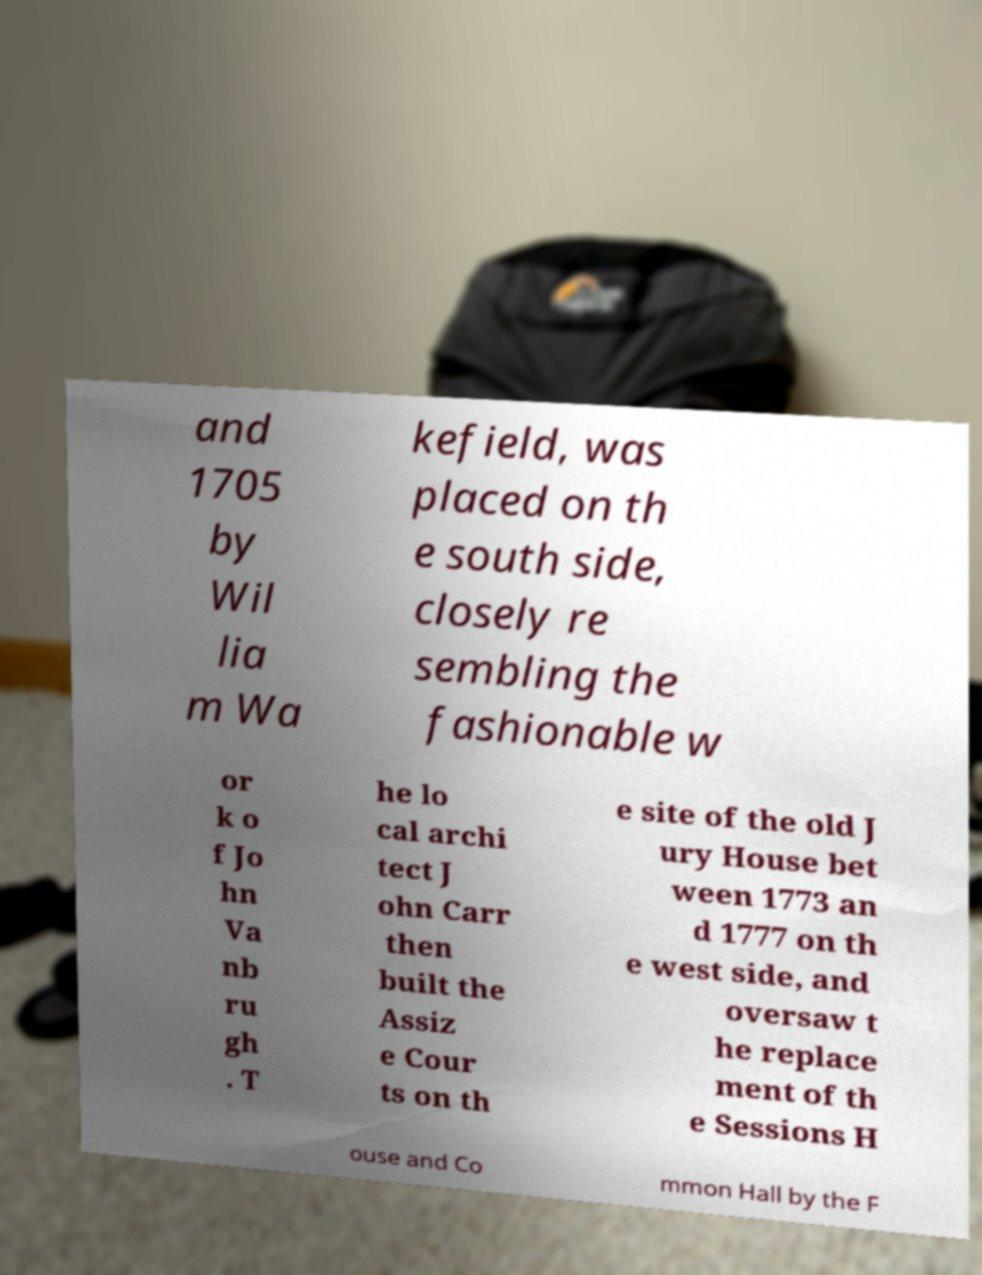Please read and relay the text visible in this image. What does it say? and 1705 by Wil lia m Wa kefield, was placed on th e south side, closely re sembling the fashionable w or k o f Jo hn Va nb ru gh . T he lo cal archi tect J ohn Carr then built the Assiz e Cour ts on th e site of the old J ury House bet ween 1773 an d 1777 on th e west side, and oversaw t he replace ment of th e Sessions H ouse and Co mmon Hall by the F 